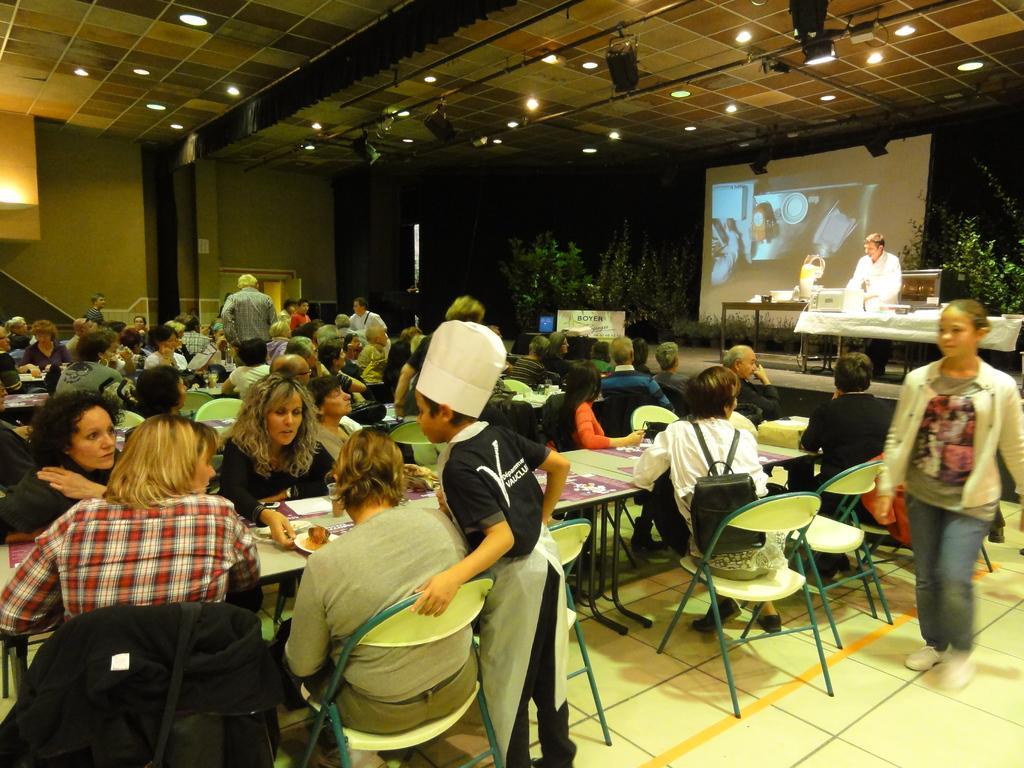How would you summarize this image in a sentence or two? In this image there are group of persons sitting on a chair, there are tables, there are objects on the tables, there are persons standing, there is a screen, there are plants, there is a board, there is text on the board, there is a wall, there is the roof towards the top of the image, there are lights on the roof. 